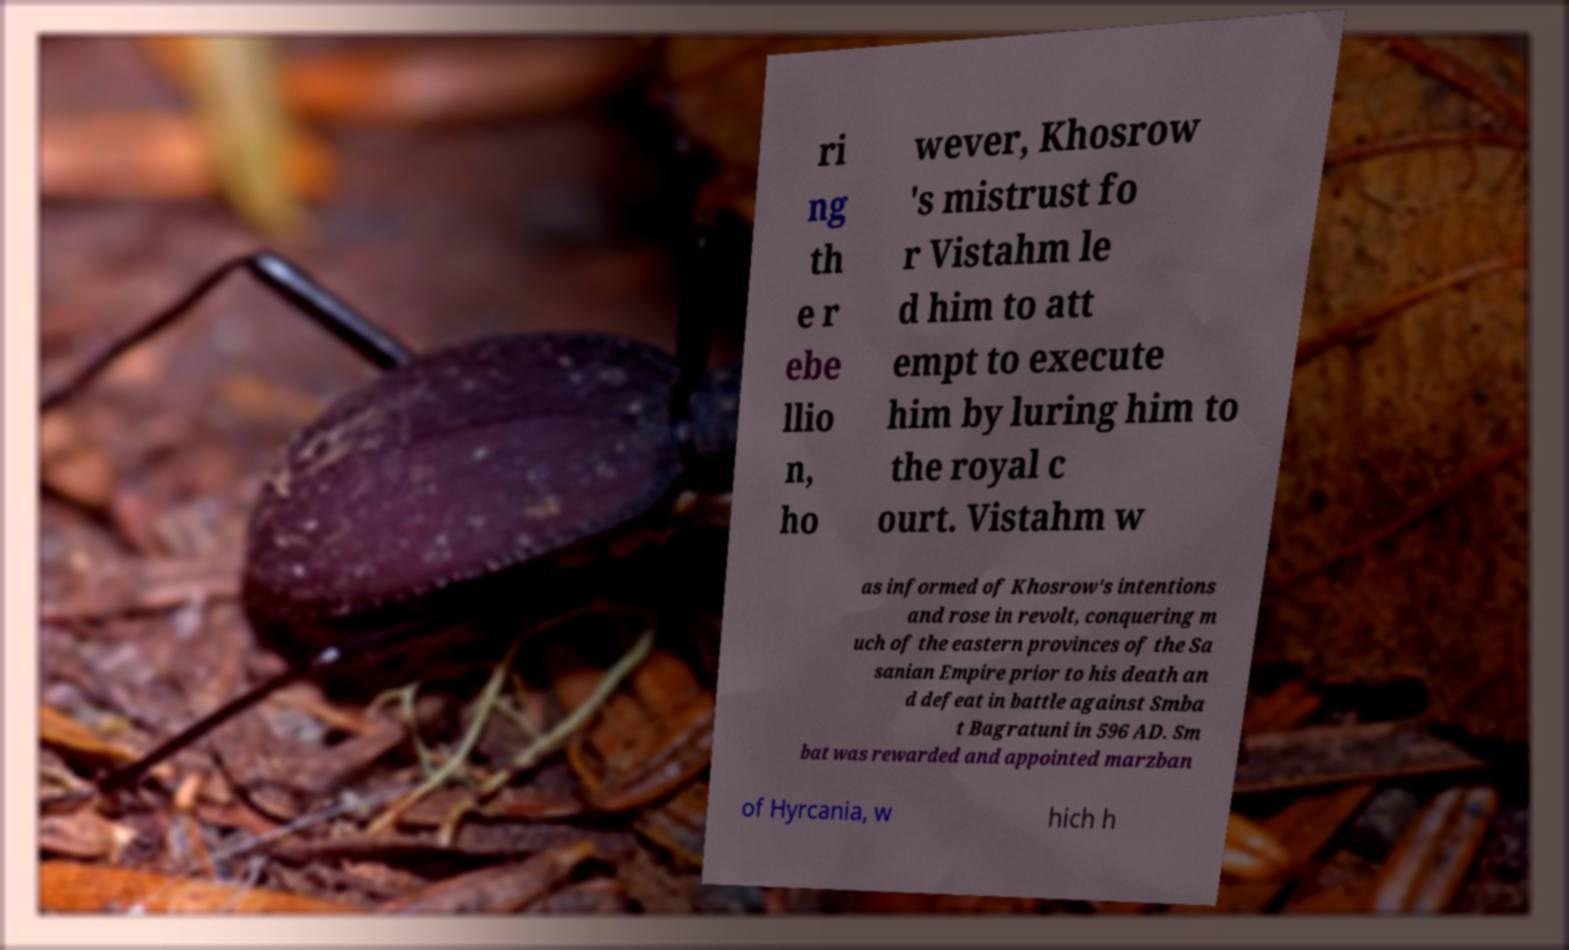Could you extract and type out the text from this image? ri ng th e r ebe llio n, ho wever, Khosrow 's mistrust fo r Vistahm le d him to att empt to execute him by luring him to the royal c ourt. Vistahm w as informed of Khosrow's intentions and rose in revolt, conquering m uch of the eastern provinces of the Sa sanian Empire prior to his death an d defeat in battle against Smba t Bagratuni in 596 AD. Sm bat was rewarded and appointed marzban of Hyrcania, w hich h 